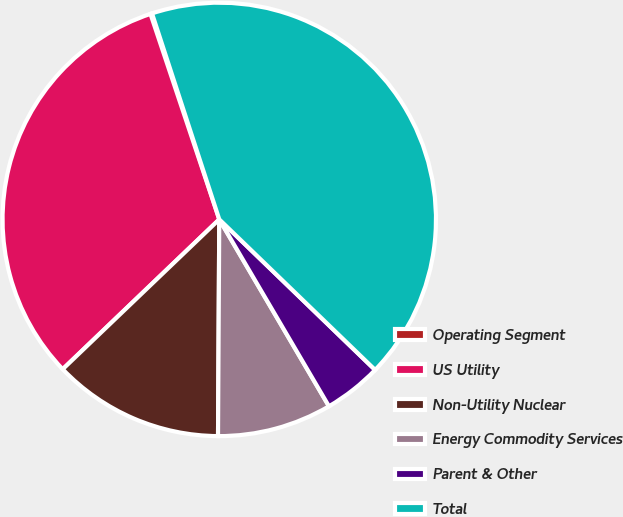Convert chart. <chart><loc_0><loc_0><loc_500><loc_500><pie_chart><fcel>Operating Segment<fcel>US Utility<fcel>Non-Utility Nuclear<fcel>Energy Commodity Services<fcel>Parent & Other<fcel>Total<nl><fcel>0.12%<fcel>32.01%<fcel>12.76%<fcel>8.54%<fcel>4.33%<fcel>42.25%<nl></chart> 